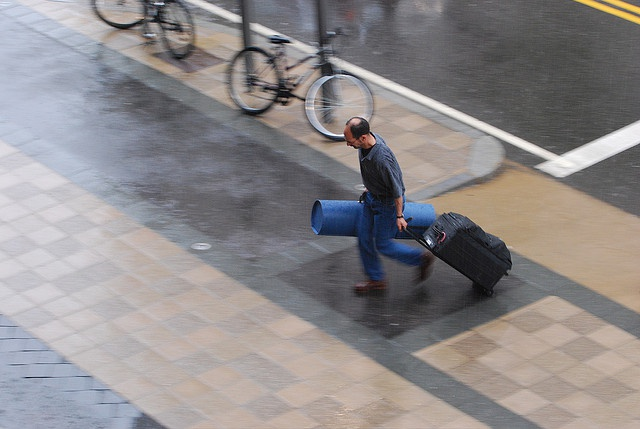Describe the objects in this image and their specific colors. I can see bicycle in lightgray, darkgray, gray, and black tones, people in lightgray, black, navy, gray, and maroon tones, suitcase in lightgray, black, gray, and darkblue tones, and bicycle in lightgray, darkgray, gray, and black tones in this image. 